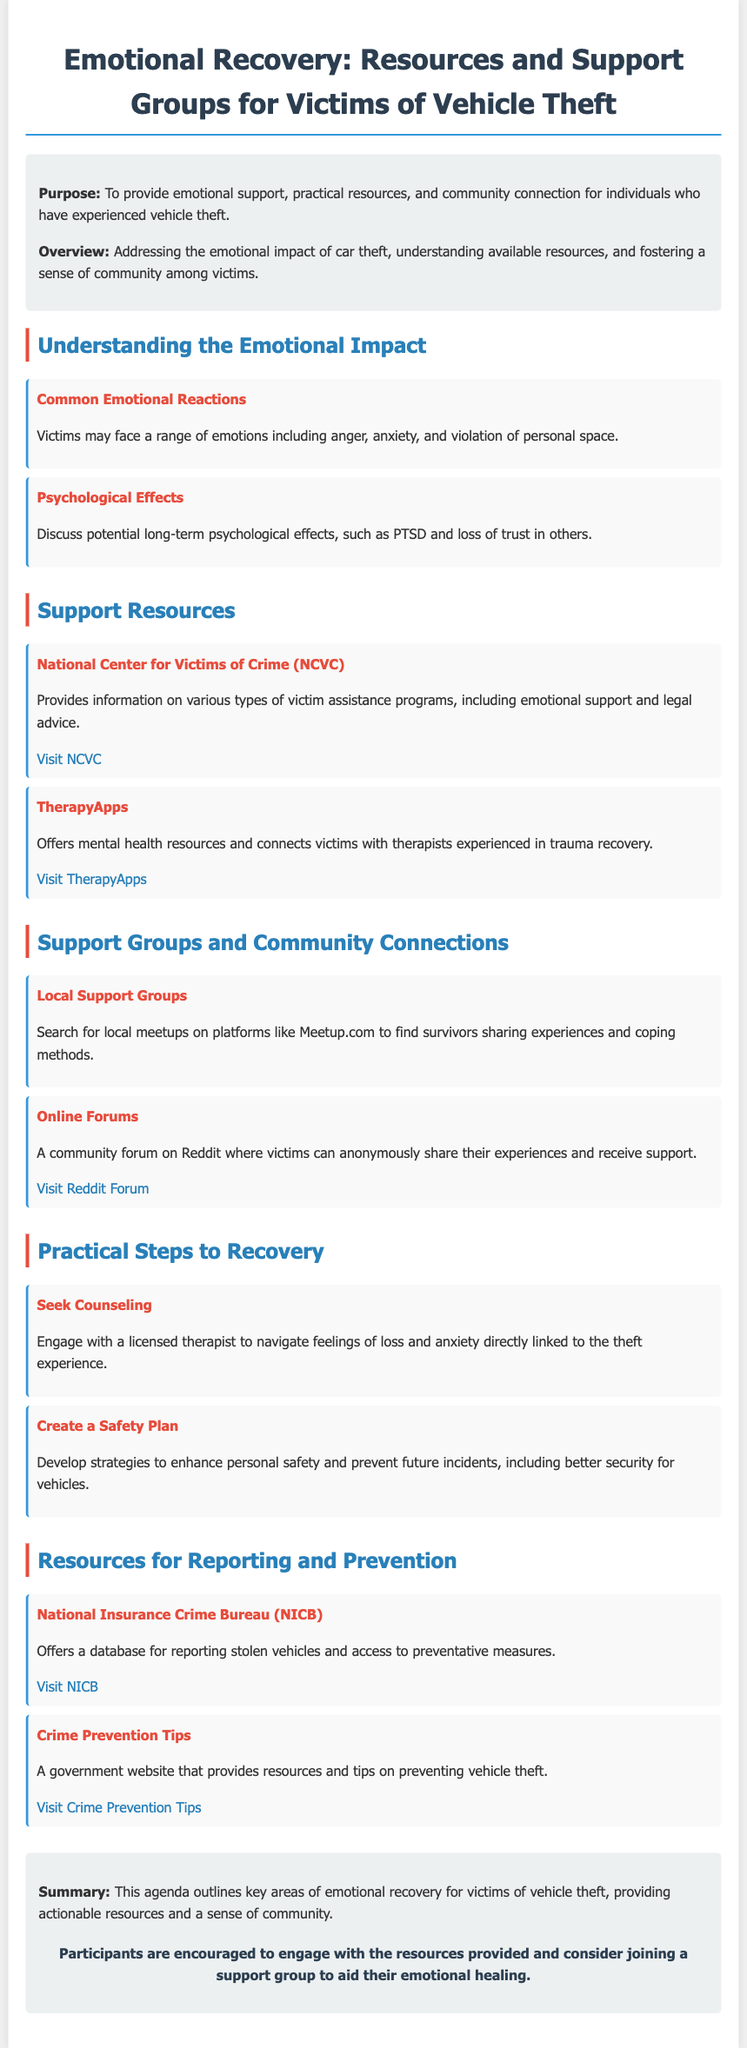what is the purpose of this document? The purpose is to provide emotional support, practical resources, and community connection for individuals who have experienced vehicle theft.
Answer: To provide emotional support, practical resources, and community connection for individuals who have experienced vehicle theft what are common emotional reactions to vehicle theft? Common emotional reactions include a range of emotions such as anger, anxiety, and violation of personal space.
Answer: Anger, anxiety, and violation of personal space which organization offers information on victim assistance programs? The National Center for Victims of Crime provides information on various types of victim assistance programs.
Answer: National Center for Victims of Crime (NCVC) what resource connects victims with therapists experienced in trauma recovery? TherapyApps offers mental health resources and connects victims with therapists experienced in trauma recovery.
Answer: TherapyApps where can victims find local meetups for support? Victims can search for local meetups on platforms like Meetup.com.
Answer: Meetup.com which online platform allows victims to anonymously share experiences? A community forum on Reddit allows victims to anonymously share their experiences.
Answer: Reddit what should victims engage in to navigate feelings of loss? Victims should engage with a licensed therapist.
Answer: Seek Counseling name one resource for reporting stolen vehicles. The National Insurance Crime Bureau offers a database for reporting stolen vehicles.
Answer: National Insurance Crime Bureau (NICB) what is advised to develop to enhance personal safety? It is advised to create a safety plan to enhance personal safety.
Answer: Create a Safety Plan 